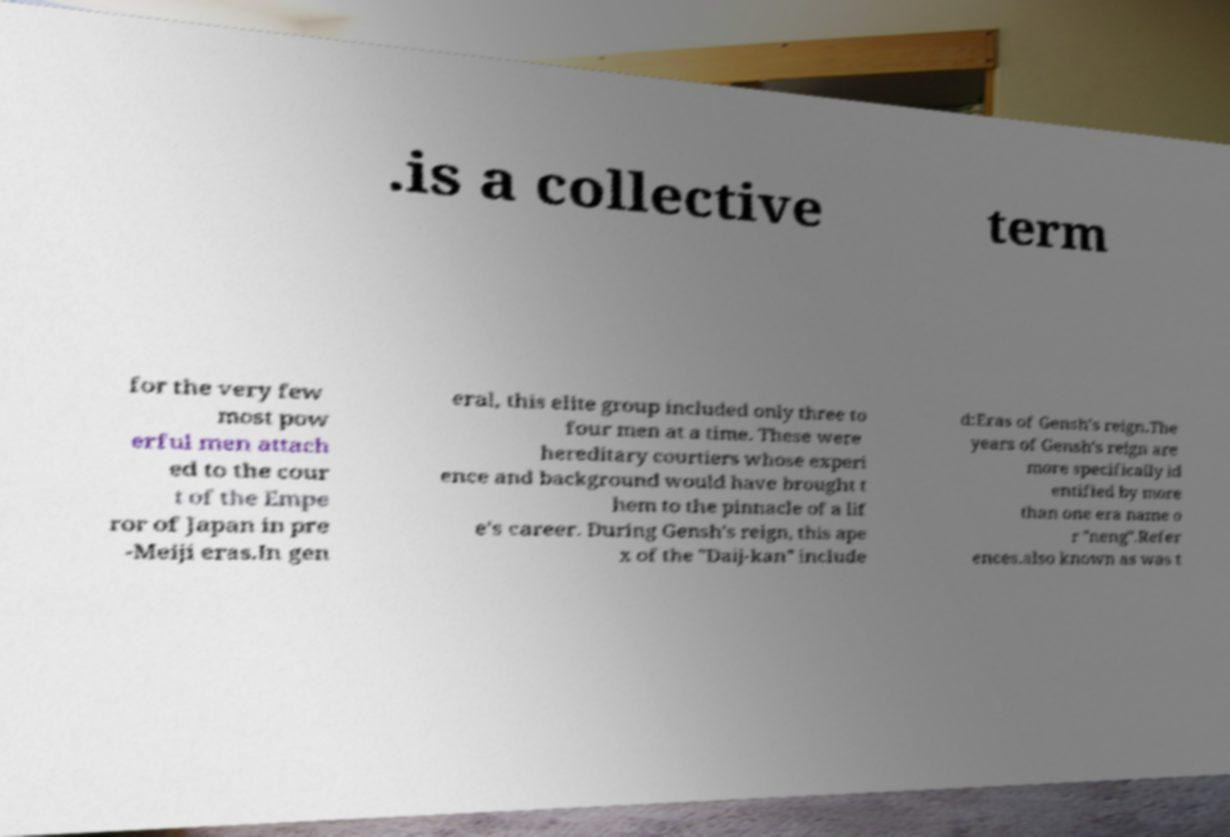Could you assist in decoding the text presented in this image and type it out clearly? .is a collective term for the very few most pow erful men attach ed to the cour t of the Empe ror of Japan in pre -Meiji eras.In gen eral, this elite group included only three to four men at a time. These were hereditary courtiers whose experi ence and background would have brought t hem to the pinnacle of a lif e's career. During Gensh's reign, this ape x of the "Daij-kan" include d:Eras of Gensh's reign.The years of Gensh's reign are more specifically id entified by more than one era name o r "neng".Refer ences.also known as was t 